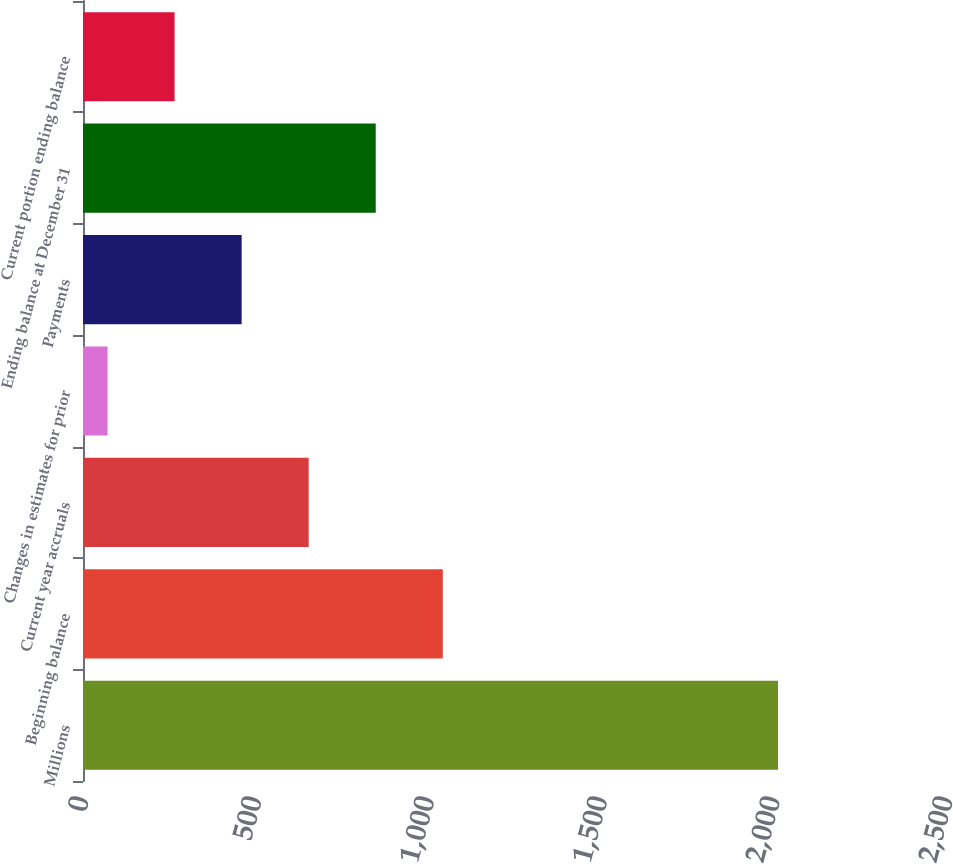Convert chart to OTSL. <chart><loc_0><loc_0><loc_500><loc_500><bar_chart><fcel>Millions<fcel>Beginning balance<fcel>Current year accruals<fcel>Changes in estimates for prior<fcel>Payments<fcel>Ending balance at December 31<fcel>Current portion ending balance<nl><fcel>2011<fcel>1041<fcel>653<fcel>71<fcel>459<fcel>847<fcel>265<nl></chart> 